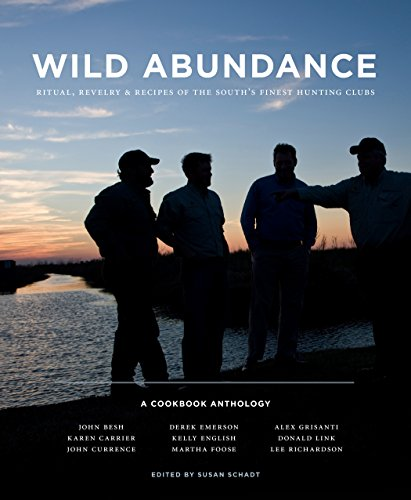What kind of recipes might one find in this book? The recipes in this anthology span a range of traditionally Southern game-based dishes, including venison, duck, and wild boar. The recipes are often flavored with local spices and ingredients, showcasing the rich culinary heritage of the South's hunting clubs. Each recipe not only provides instructions but also weaves in narratives of the dish’s significance or its origins within the community. 